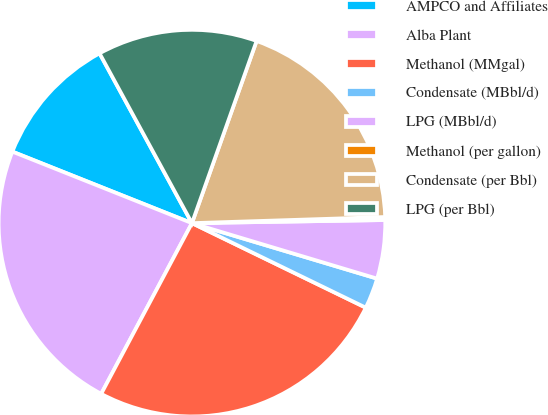<chart> <loc_0><loc_0><loc_500><loc_500><pie_chart><fcel>AMPCO and Affiliates<fcel>Alba Plant<fcel>Methanol (MMgal)<fcel>Condensate (MBbl/d)<fcel>LPG (MBbl/d)<fcel>Methanol (per gallon)<fcel>Condensate (per Bbl)<fcel>LPG (per Bbl)<nl><fcel>11.04%<fcel>23.26%<fcel>25.58%<fcel>2.57%<fcel>4.89%<fcel>0.25%<fcel>19.07%<fcel>13.36%<nl></chart> 